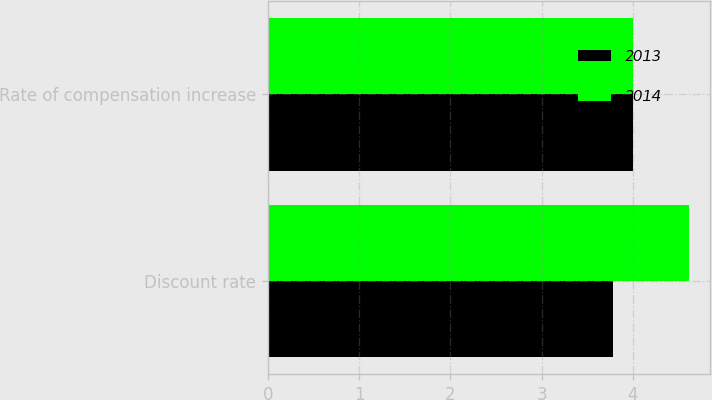Convert chart to OTSL. <chart><loc_0><loc_0><loc_500><loc_500><stacked_bar_chart><ecel><fcel>Discount rate<fcel>Rate of compensation increase<nl><fcel>2013<fcel>3.78<fcel>4<nl><fcel>2014<fcel>4.61<fcel>4<nl></chart> 